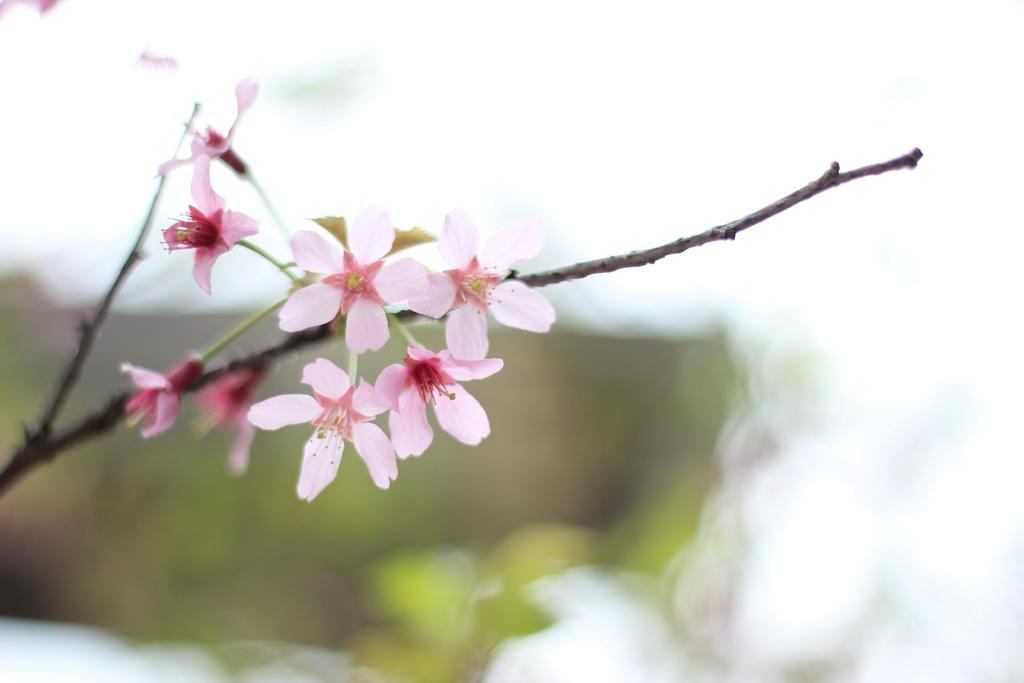What type of plants can be seen in the image? There are flowers in the image. How are the flowers arranged or positioned? The flowers are on branches. Can you describe the background of the image? The background of the image is blurred. What type of legal advice can be obtained from the flowers in the image? There are no lawyers or legal advice present in the image; it features flowers on branches. Can you describe the texture of the cushion in the image? There is no cushion present in the image. 